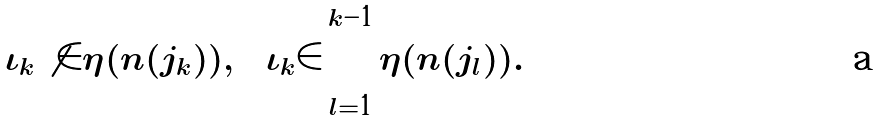Convert formula to latex. <formula><loc_0><loc_0><loc_500><loc_500>\iota _ { k } \not \in \eta ( n ( j _ { k } ) ) , \quad \iota _ { k } \in \bigcap _ { l = 1 } ^ { k - 1 } \eta ( n ( j _ { l } ) ) .</formula> 